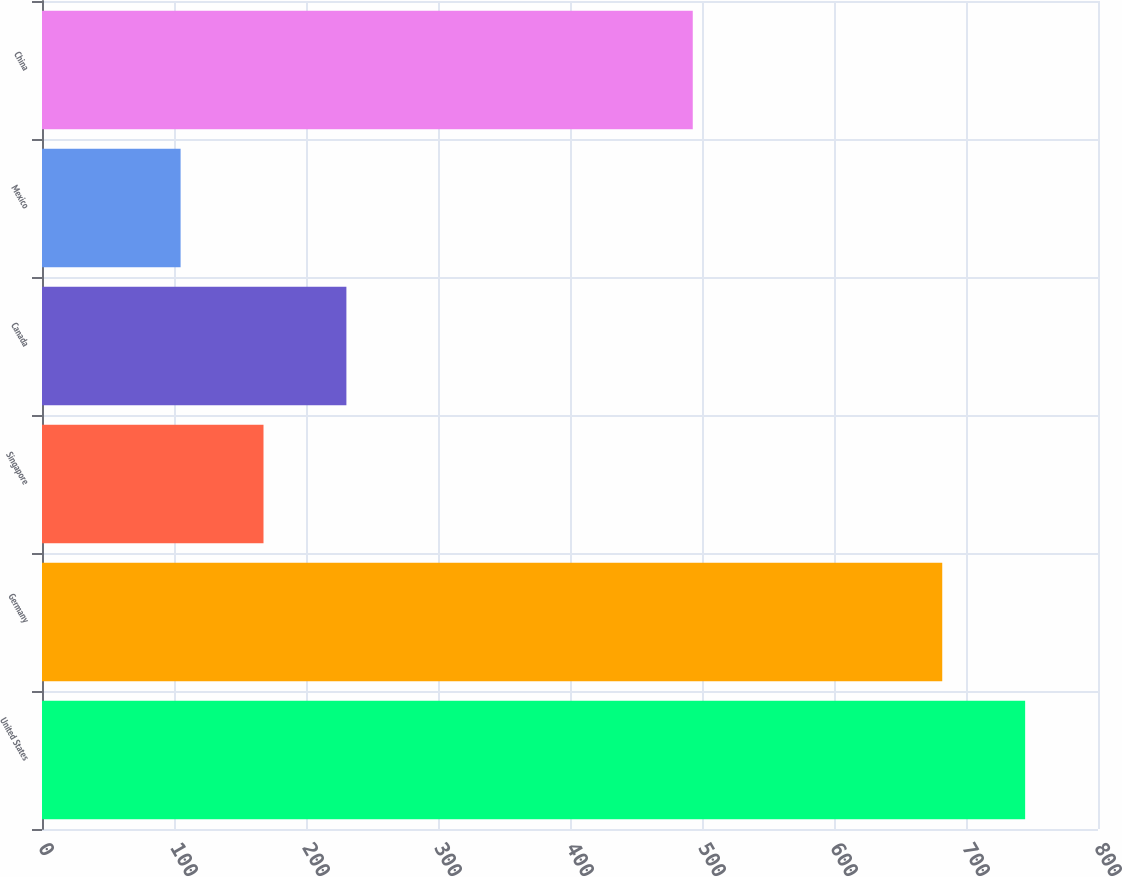<chart> <loc_0><loc_0><loc_500><loc_500><bar_chart><fcel>United States<fcel>Germany<fcel>Singapore<fcel>Canada<fcel>Mexico<fcel>China<nl><fcel>744.8<fcel>682<fcel>167.8<fcel>230.6<fcel>105<fcel>493<nl></chart> 